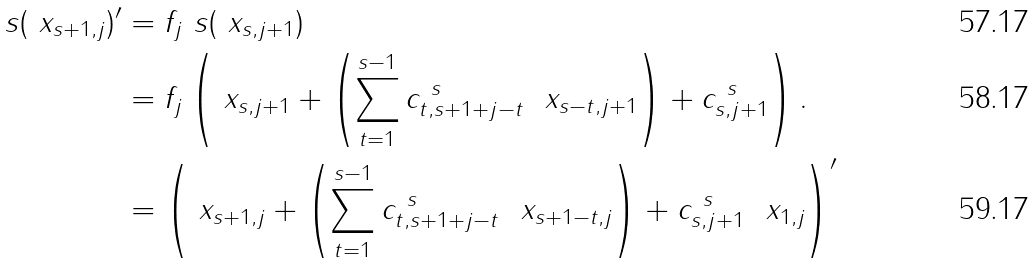<formula> <loc_0><loc_0><loc_500><loc_500>\ s ( \ x _ { s + 1 , j } ) ^ { \prime } & = f _ { j } \ s ( \ x _ { s , j + 1 } ) \\ & = f _ { j } \left ( \ x _ { s , j + 1 } + \left ( \sum ^ { s - 1 } _ { t = 1 } c ^ { \ s } _ { t , s + 1 + j - t } \ \ x _ { s - t , j + 1 } \right ) + c ^ { \ s } _ { s , j + 1 } \right ) . \\ & = \left ( \ x _ { s + 1 , j } + \left ( \sum ^ { s - 1 } _ { t = 1 } c ^ { \ s } _ { t , s + 1 + j - t } \ \ x _ { s + 1 - t , j } \right ) + c ^ { \ s } _ { s , j + 1 } \ \ x _ { 1 , j } \right ) ^ { \prime }</formula> 